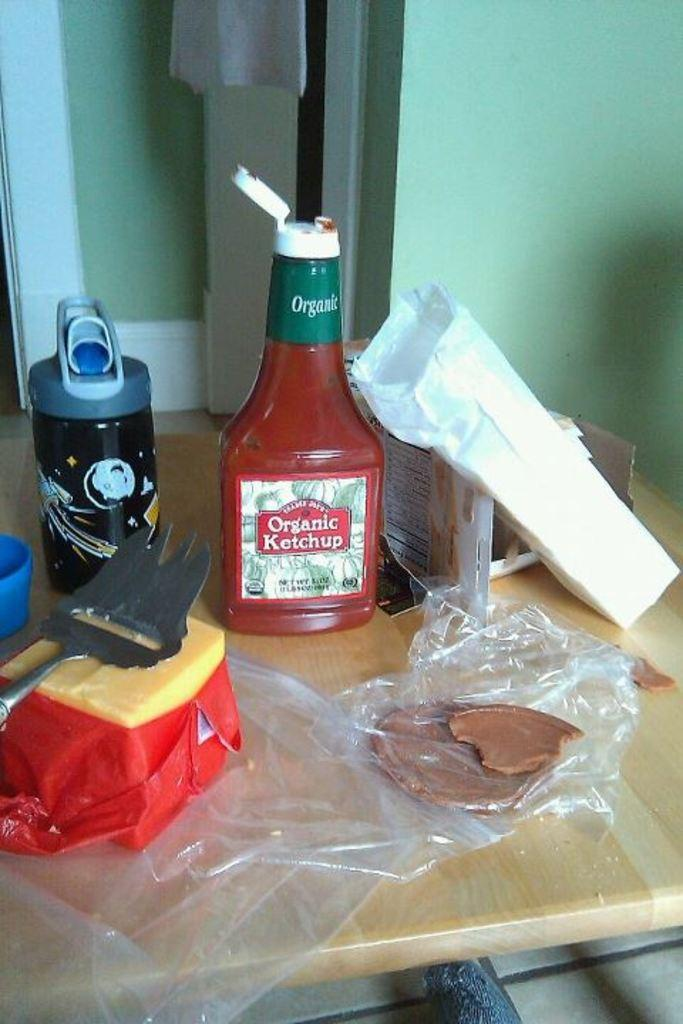<image>
Relay a brief, clear account of the picture shown. A bottle of Organic Ketchup waits to be used on a table. 